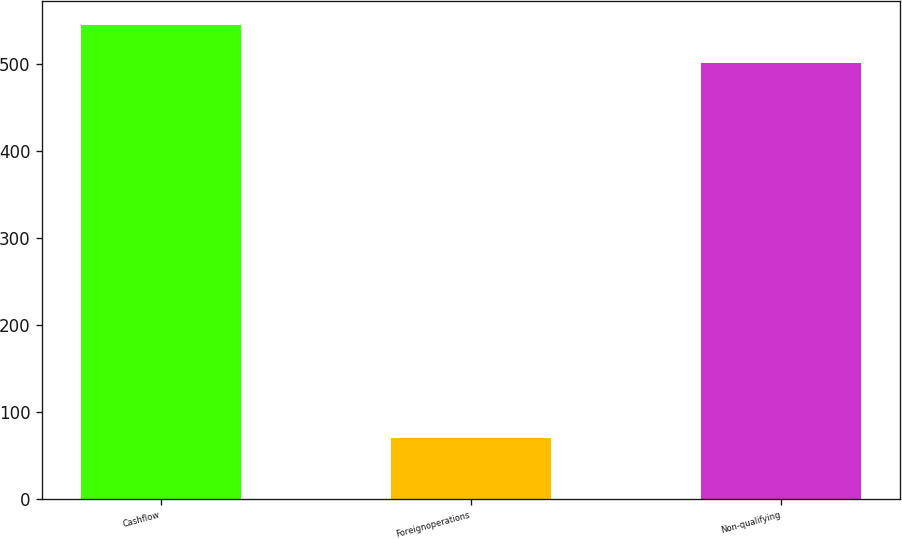Convert chart to OTSL. <chart><loc_0><loc_0><loc_500><loc_500><bar_chart><fcel>Cashflow<fcel>Foreignoperations<fcel>Non-qualifying<nl><fcel>545.5<fcel>70<fcel>502<nl></chart> 